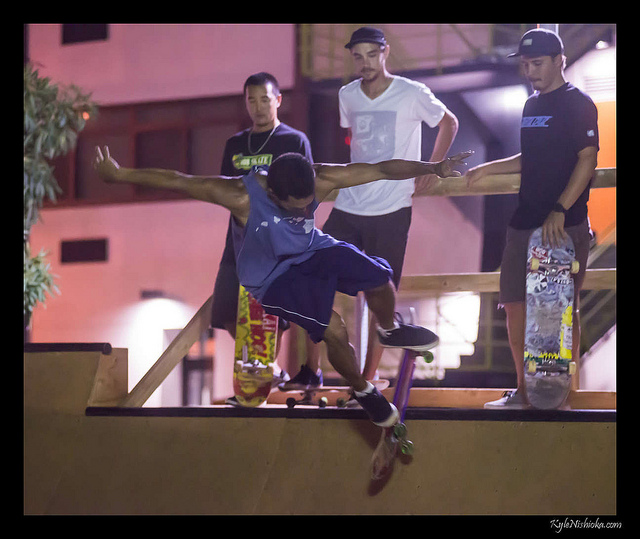Read and extract the text from this image. kyleNishioha.com 